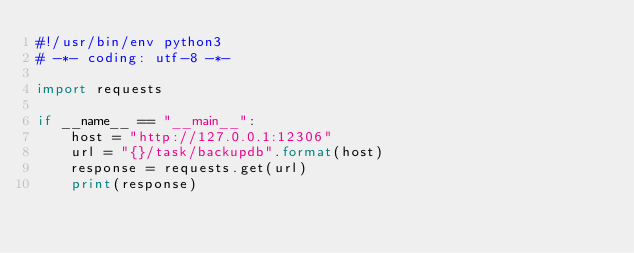Convert code to text. <code><loc_0><loc_0><loc_500><loc_500><_Python_>#!/usr/bin/env python3
# -*- coding: utf-8 -*-

import requests

if __name__ == "__main__":
    host = "http://127.0.0.1:12306"
    url = "{}/task/backupdb".format(host)
    response = requests.get(url)
    print(response)</code> 